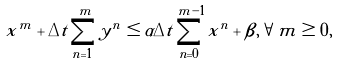<formula> <loc_0><loc_0><loc_500><loc_500>x ^ { m } + \Delta t \sum _ { n = 1 } ^ { m } y ^ { n } \leq \alpha \Delta t \sum _ { n = 0 } ^ { m - 1 } x ^ { n } + \beta , \forall m \geq 0 ,</formula> 